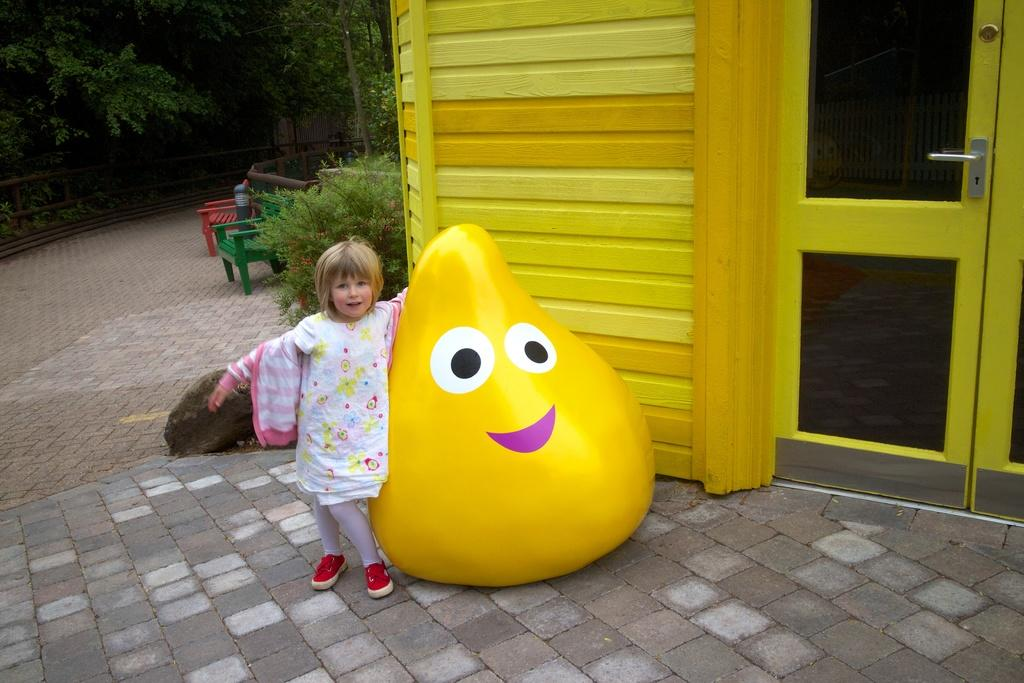Who is the main subject in the image? There is a little girl in the image. What is the little girl doing in the image? The girl is standing beside a toy. What can be seen on the right side of the image? There is a house on the right side of the image. What type of natural environment is visible in the background of the image? There are trees in the background of the image. What type of cushion is the little girl sitting on in the image? There is no cushion present in the image; the girl is standing beside a toy. 